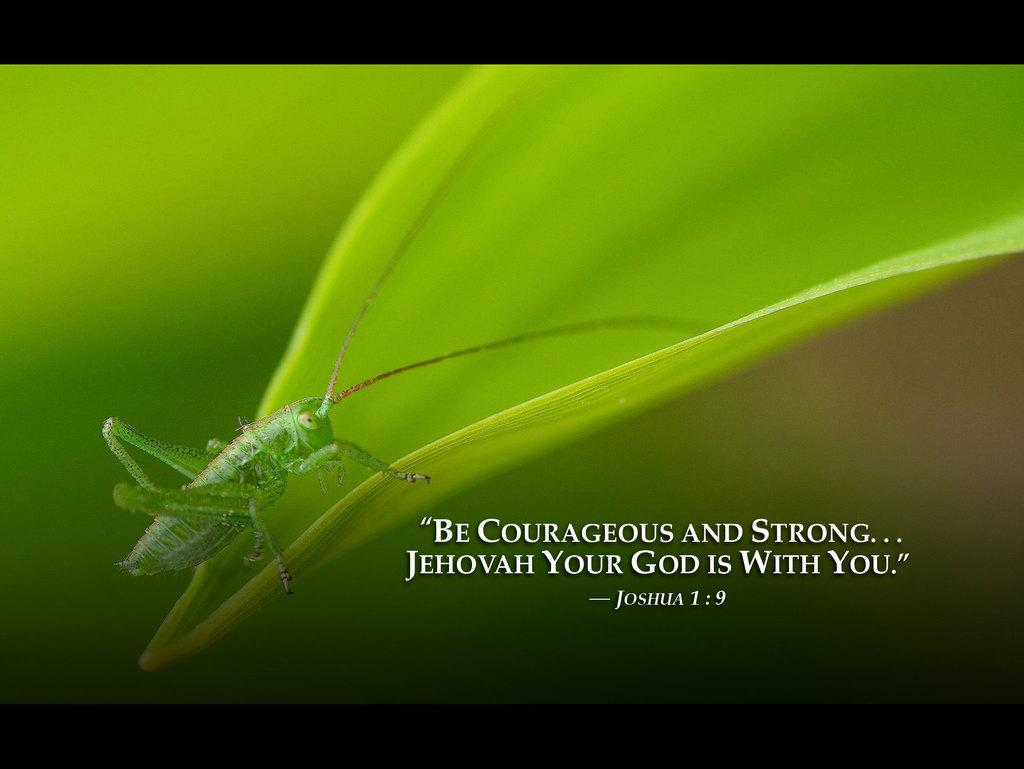What type of insect is in the image? There is a green color grasshopper in the image. What is the grasshopper resting on? The grasshopper is on a green color leaf. How would you describe the background of the image? The background of the image is blurred. Is there any text in the image? Yes, there is edited text at the bottom of the image. What type of rock is the grasshopper smashing in the image? There is no rock present in the image, and the grasshopper is not smashing anything. 